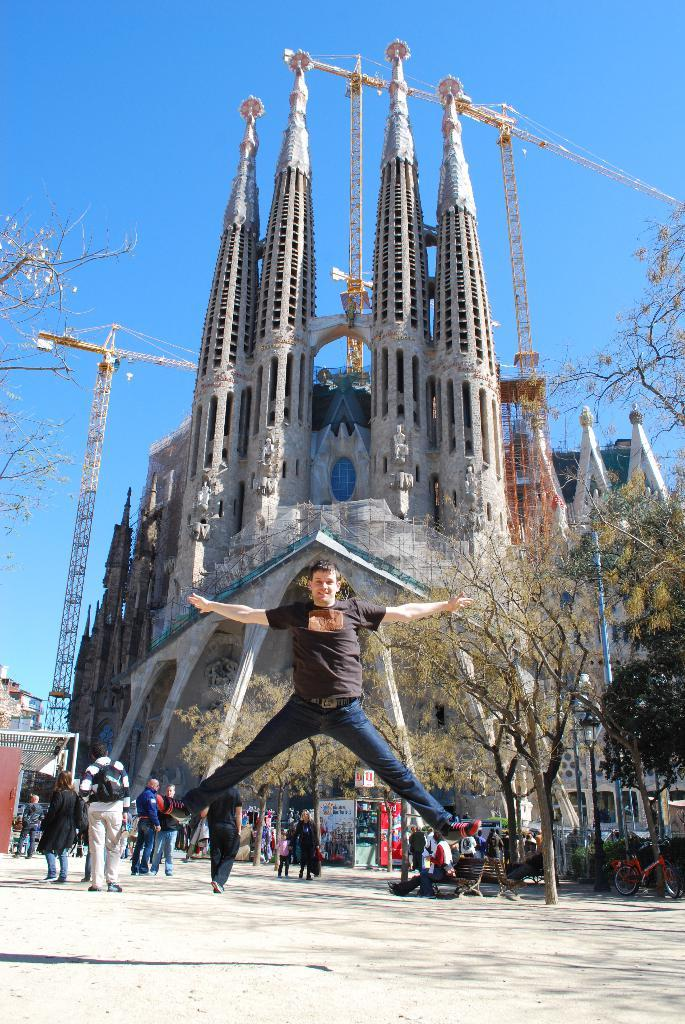What type of structures can be seen in the image? There are buildings, a castle, and cranes in the image. What else can be found in the image besides structures? There are trees, stores, bicycles, and people in the image. What are some of the activities people are engaged in within the image? Some people are sitting on a bench, while others might be shopping or working. What is the color of the sky in the image? The sky is blue in the image. Is the mother of the person taking the picture visible in the image? There is no information about the person taking the picture or their mother in the provided facts, so we cannot determine if the mother is visible in the image. Are the bicycles hot in the image? The provided facts do not mention the temperature of the bicycles or any other objects in the image, so we cannot determine if they are hot. 